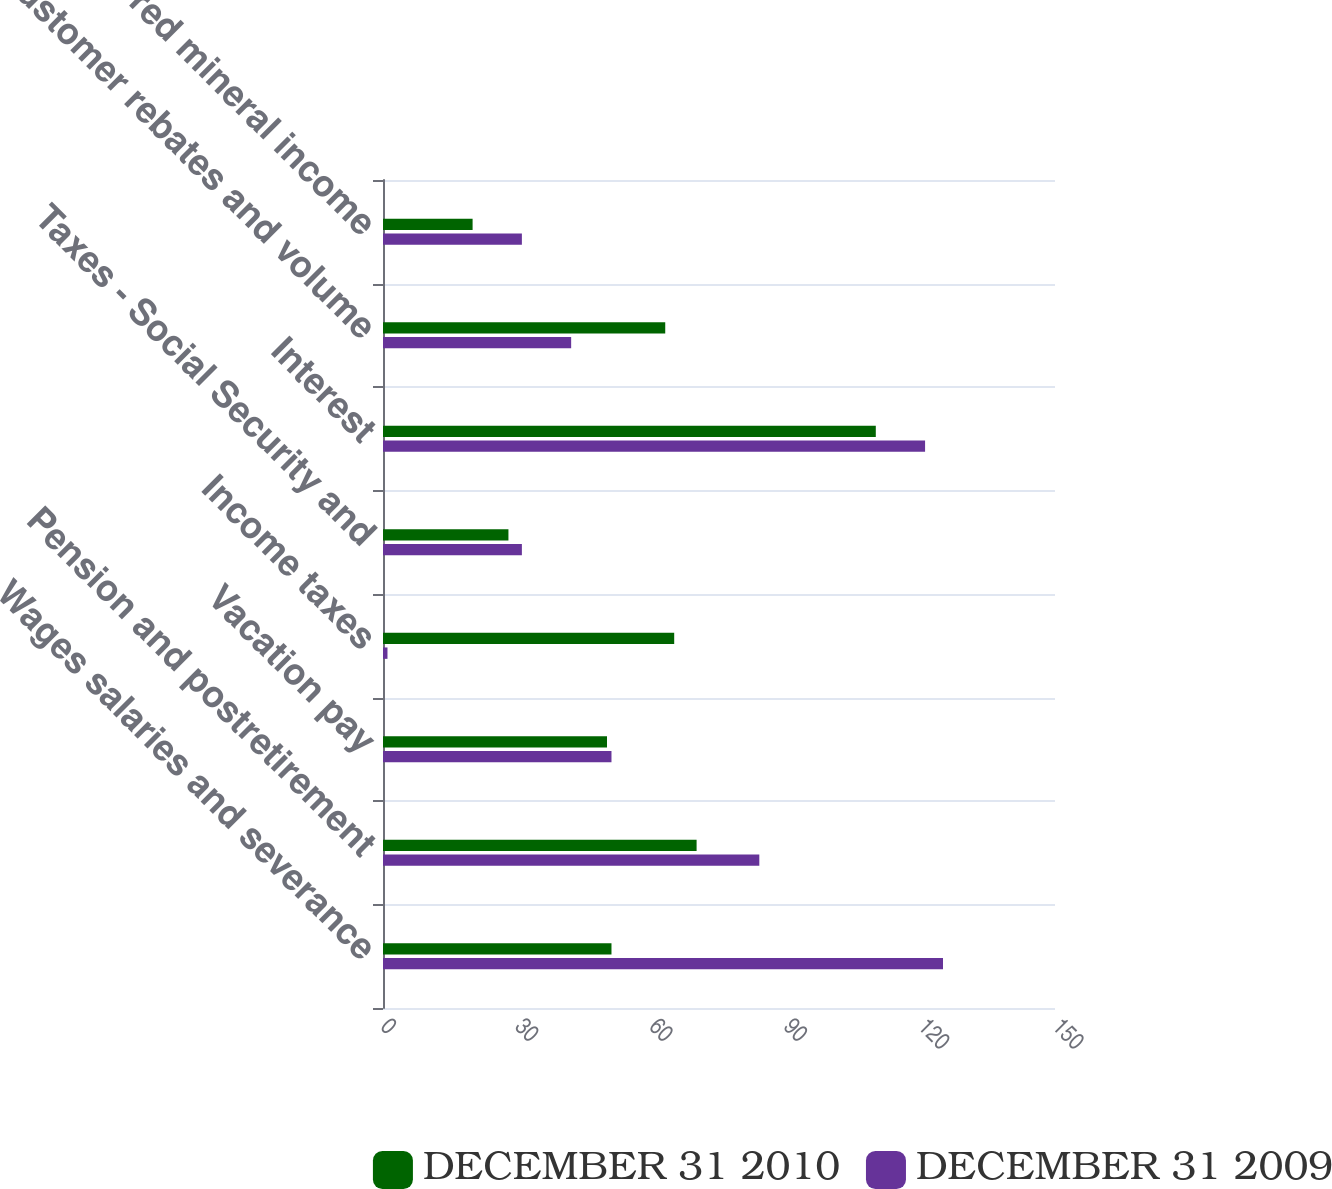Convert chart. <chart><loc_0><loc_0><loc_500><loc_500><stacked_bar_chart><ecel><fcel>Wages salaries and severance<fcel>Pension and postretirement<fcel>Vacation pay<fcel>Income taxes<fcel>Taxes - Social Security and<fcel>Interest<fcel>Customer rebates and volume<fcel>Deferred mineral income<nl><fcel>DECEMBER 31 2010<fcel>51<fcel>70<fcel>50<fcel>65<fcel>28<fcel>110<fcel>63<fcel>20<nl><fcel>DECEMBER 31 2009<fcel>125<fcel>84<fcel>51<fcel>1<fcel>31<fcel>121<fcel>42<fcel>31<nl></chart> 